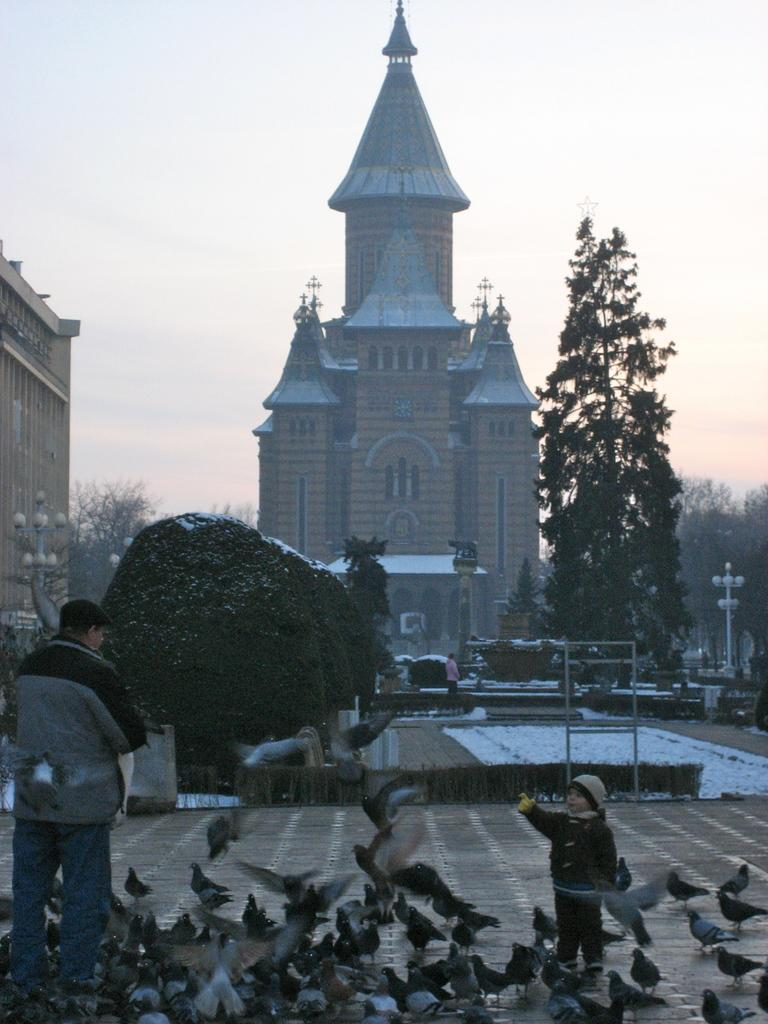What is happening on the ground in the image? There are people on the ground in the image. What type of animals can be seen in the image? Birds are visible in the image. What can be seen in the background of the image? Buildings, trees, poles with lights, and the sky are present in the background of the image. What color is the cushion on the bird's head in the image? There is no cushion present on any bird's head in the image. What type of haircut does the person in the image have? The provided facts do not mention any specific haircuts or people's appearances, so we cannot determine the haircut of anyone in the image. 